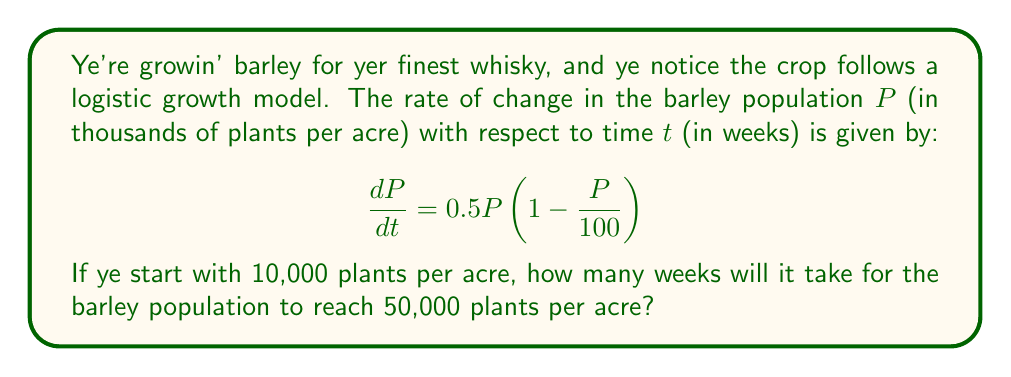Could you help me with this problem? Let's approach this step-by-step:

1) The given differential equation is a logistic growth model:

   $$\frac{dP}{dt} = 0.5P(1 - \frac{P}{100})$$

2) The solution to this logistic equation is:

   $$P(t) = \frac{100}{1 + (\frac{100}{P_0} - 1)e^{-0.5t}}$$

   Where $P_0$ is the initial population.

3) We're given that $P_0 = 10$ (remember, P is in thousands of plants per acre), and we want to find t when $P(t) = 50$.

4) Let's substitute these values into our equation:

   $$50 = \frac{100}{1 + (\frac{100}{10} - 1)e^{-0.5t}}$$

5) Now, let's solve for t:

   $$1 + (\frac{100}{10} - 1)e^{-0.5t} = \frac{100}{50} = 2$$
   
   $$(\frac{100}{10} - 1)e^{-0.5t} = 1$$
   
   $$9e^{-0.5t} = 1$$
   
   $$e^{-0.5t} = \frac{1}{9}$$

6) Taking the natural log of both sides:

   $$-0.5t = \ln(\frac{1}{9}) = -\ln(9)$$

7) Solving for t:

   $$t = \frac{2\ln(9)}{0.5} = 4\ln(9) \approx 8.78$$

Therefore, it will take approximately 8.78 weeks for the barley population to reach 50,000 plants per acre.
Answer: $t \approx 8.78$ weeks 